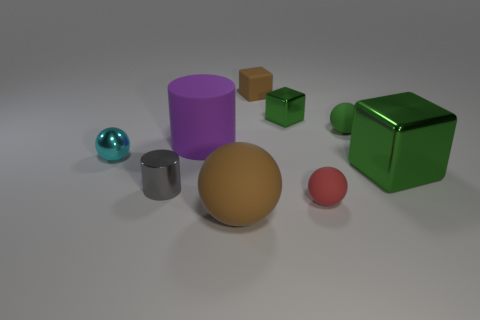Subtract all matte cubes. How many cubes are left? 2 Subtract all cyan balls. How many balls are left? 3 Subtract all blue cylinders. How many green cubes are left? 2 Subtract all big gray metal cubes. Subtract all big matte cylinders. How many objects are left? 8 Add 7 green blocks. How many green blocks are left? 9 Add 6 brown blocks. How many brown blocks exist? 7 Subtract 1 brown spheres. How many objects are left? 8 Subtract all cylinders. How many objects are left? 7 Subtract all green cylinders. Subtract all gray blocks. How many cylinders are left? 2 